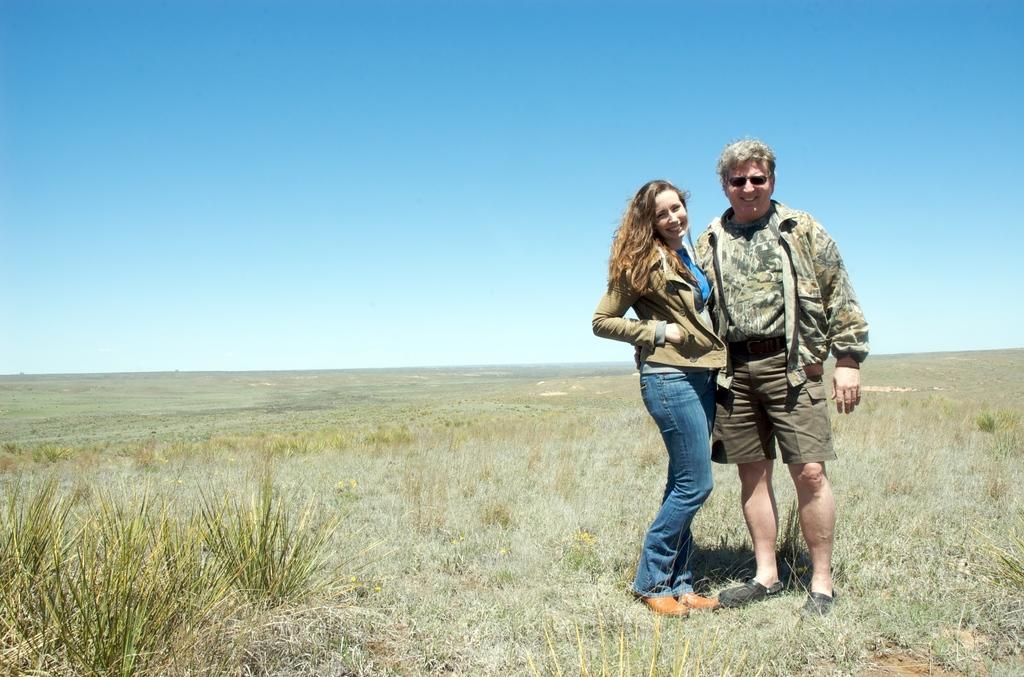Describe this image in one or two sentences. In this image, there are a few people. We can see the ground with some grass and plants. We can also see the sky. 